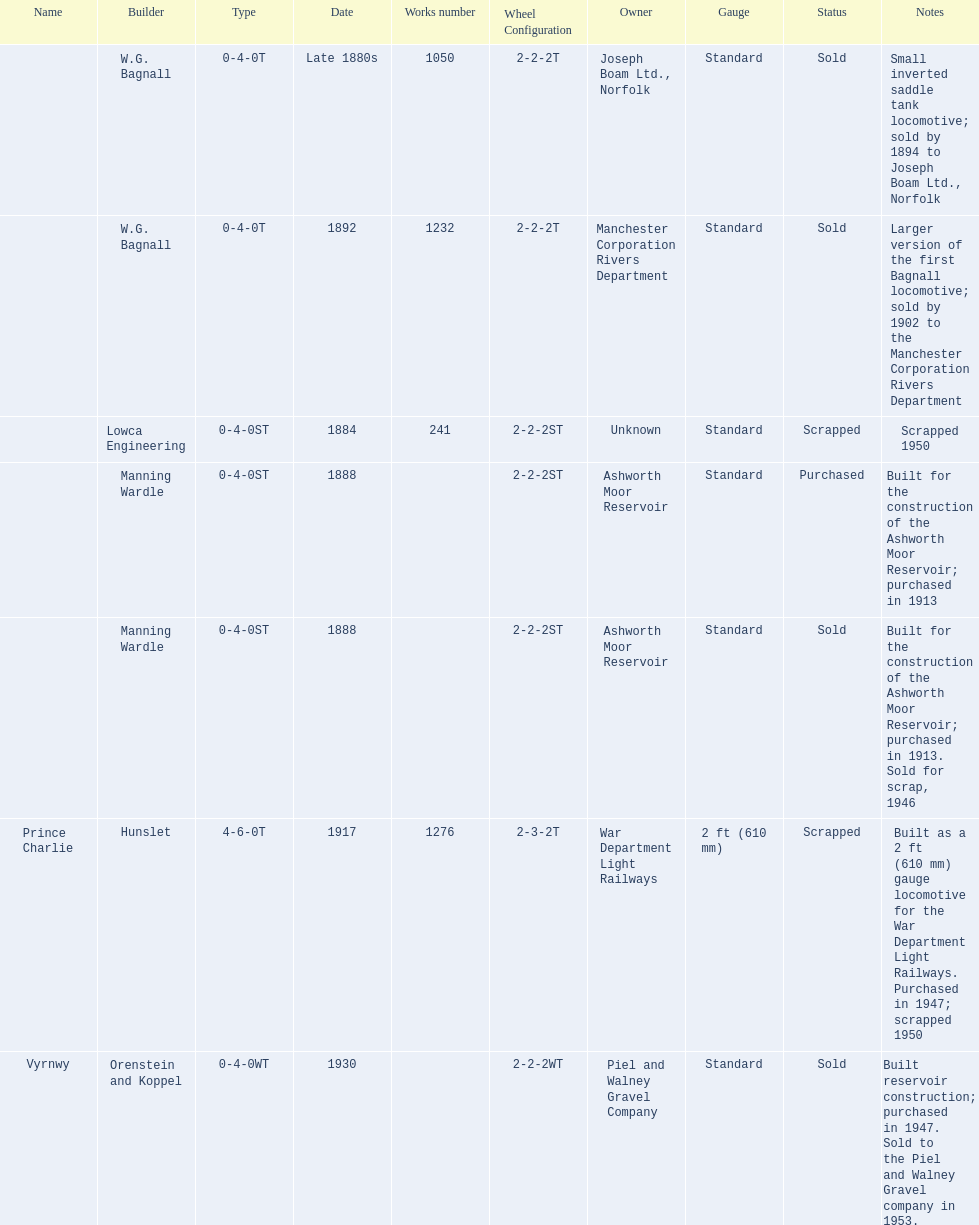How many locomotives were built before the 1900s? 5. 